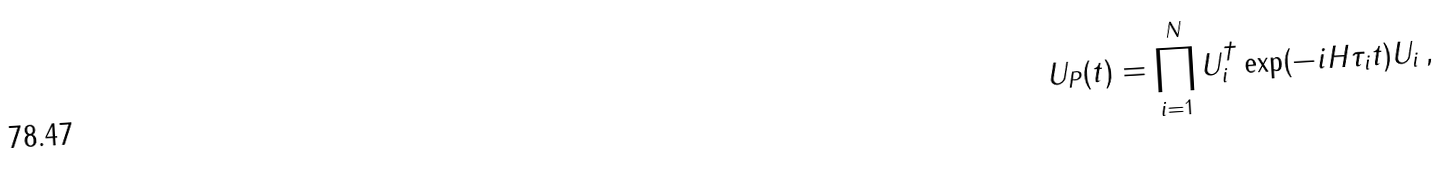Convert formula to latex. <formula><loc_0><loc_0><loc_500><loc_500>U _ { P } ( t ) = \prod _ { i = 1 } ^ { N } U _ { i } ^ { \dagger } \exp ( - i H \tau _ { i } t ) U _ { i } \, ,</formula> 